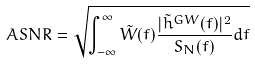Convert formula to latex. <formula><loc_0><loc_0><loc_500><loc_500>A S N R = \sqrt { \int _ { - \infty } ^ { \infty } \tilde { W } ( f ) \frac { | \tilde { h } ^ { G W } ( f ) | ^ { 2 } } { S _ { N } ( f ) } d f }</formula> 